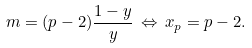<formula> <loc_0><loc_0><loc_500><loc_500>m = ( p - 2 ) \frac { 1 - y } { y } \, \Leftrightarrow \, x _ { p } = p - 2 .</formula> 